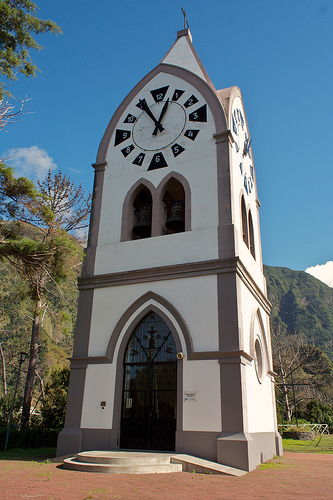Where is that grass? The grass is located on the ground near the base of the clock tower. 